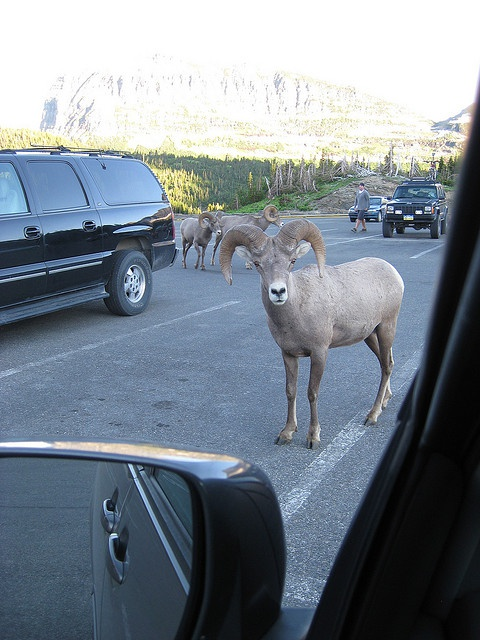Describe the objects in this image and their specific colors. I can see truck in white, black, lightblue, gray, and darkgray tones, sheep in white, darkgray, gray, and lightgray tones, car in white, black, navy, blue, and gray tones, sheep in white, gray, and darkgray tones, and sheep in white, darkgray, and gray tones in this image. 